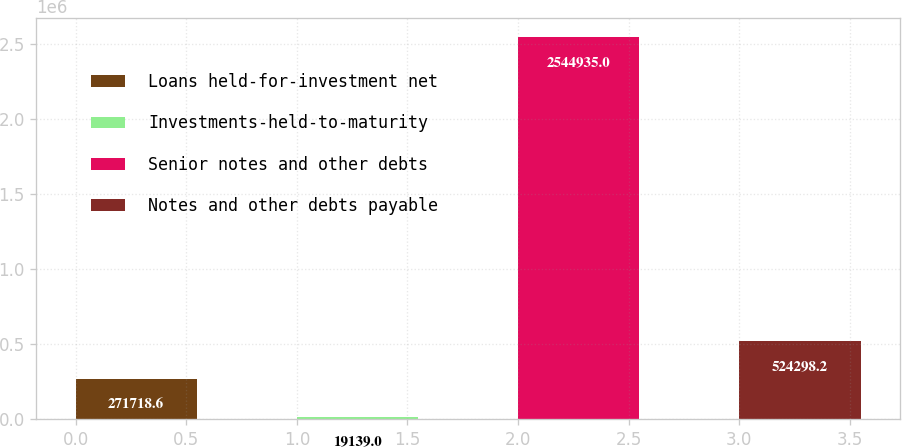<chart> <loc_0><loc_0><loc_500><loc_500><bar_chart><fcel>Loans held-for-investment net<fcel>Investments-held-to-maturity<fcel>Senior notes and other debts<fcel>Notes and other debts payable<nl><fcel>271719<fcel>19139<fcel>2.54494e+06<fcel>524298<nl></chart> 